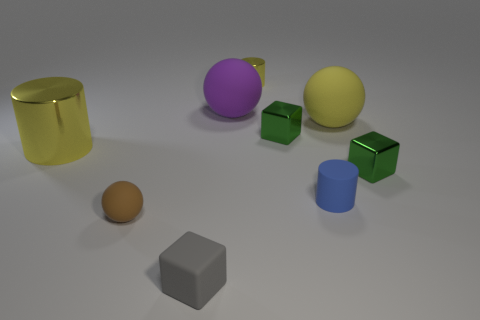What is the material of the object that is in front of the big yellow matte object and on the right side of the tiny blue cylinder?
Keep it short and to the point. Metal. The big cylinder is what color?
Make the answer very short. Yellow. What number of blue rubber things have the same shape as the big yellow rubber object?
Provide a short and direct response. 0. Are the sphere right of the small blue matte thing and the yellow cylinder that is to the left of the brown sphere made of the same material?
Keep it short and to the point. No. What is the size of the green metallic thing to the right of the sphere to the right of the rubber cylinder?
Offer a very short reply. Small. Is there any other thing that has the same size as the purple rubber sphere?
Your answer should be compact. Yes. There is a yellow thing that is the same shape as the brown object; what is it made of?
Your answer should be compact. Rubber. Do the big rubber object to the right of the large purple ball and the yellow shiny thing that is left of the small gray cube have the same shape?
Your response must be concise. No. Is the number of large yellow things greater than the number of tiny gray matte objects?
Provide a short and direct response. Yes. What is the size of the purple object?
Give a very brief answer. Large. 